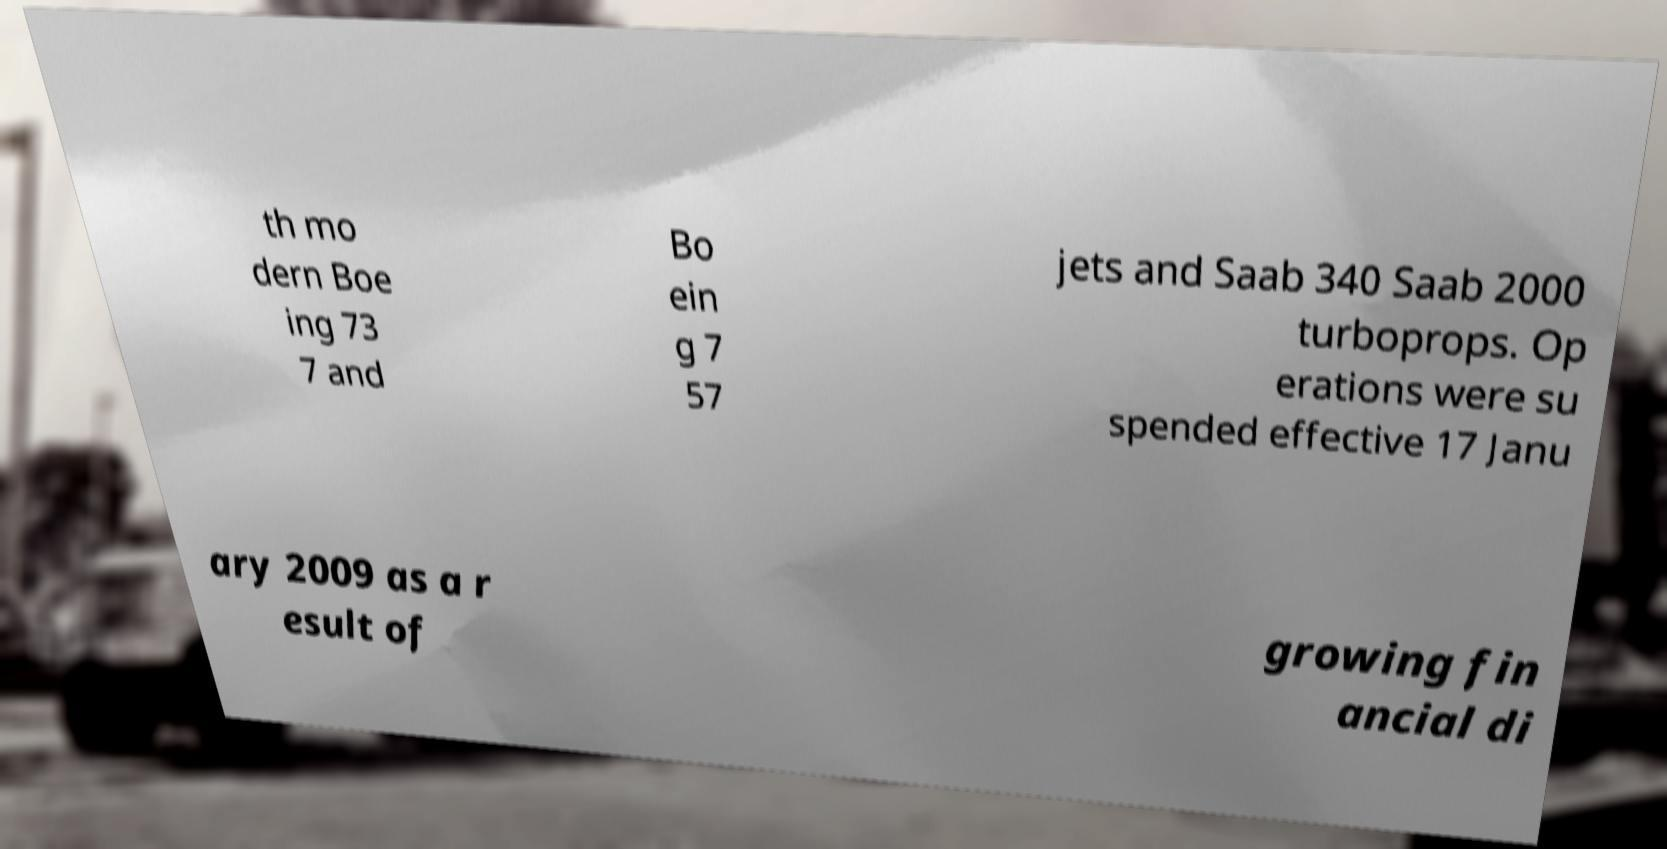Can you read and provide the text displayed in the image?This photo seems to have some interesting text. Can you extract and type it out for me? th mo dern Boe ing 73 7 and Bo ein g 7 57 jets and Saab 340 Saab 2000 turboprops. Op erations were su spended effective 17 Janu ary 2009 as a r esult of growing fin ancial di 